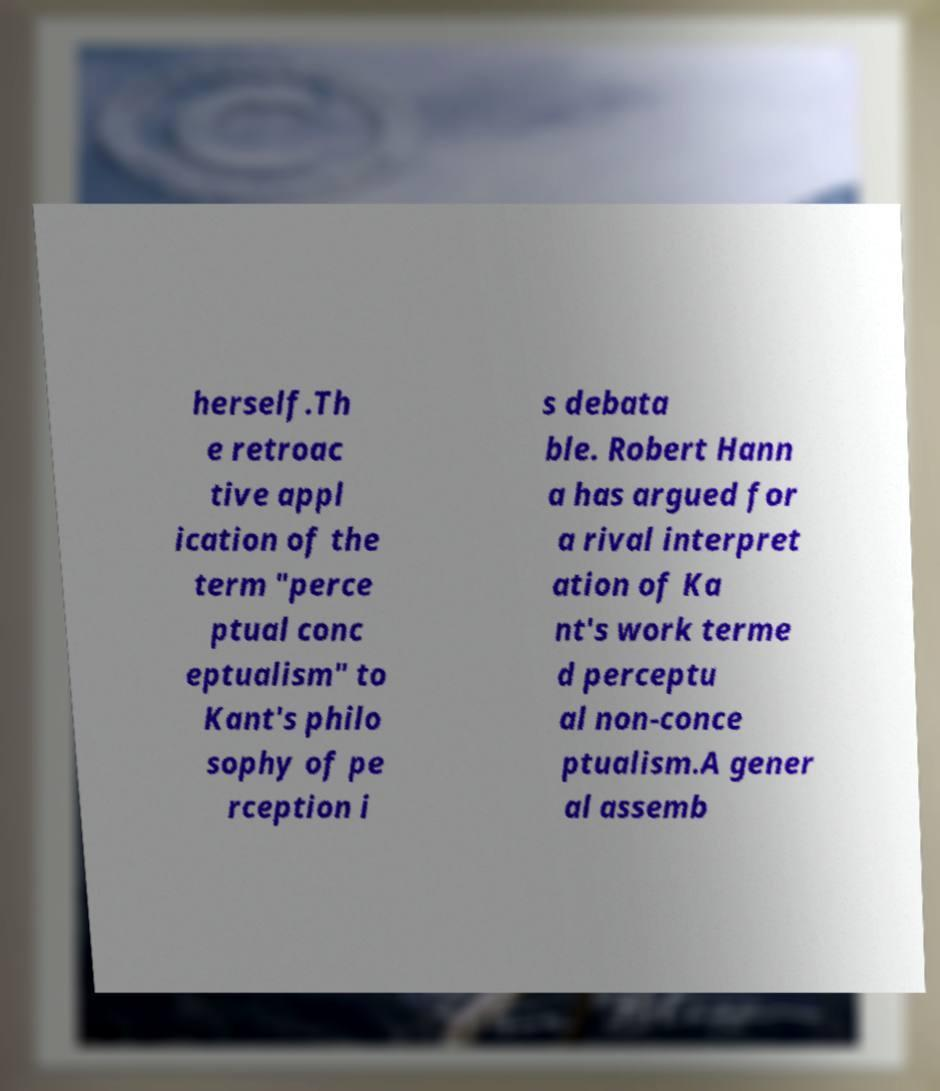Could you assist in decoding the text presented in this image and type it out clearly? herself.Th e retroac tive appl ication of the term "perce ptual conc eptualism" to Kant's philo sophy of pe rception i s debata ble. Robert Hann a has argued for a rival interpret ation of Ka nt's work terme d perceptu al non-conce ptualism.A gener al assemb 